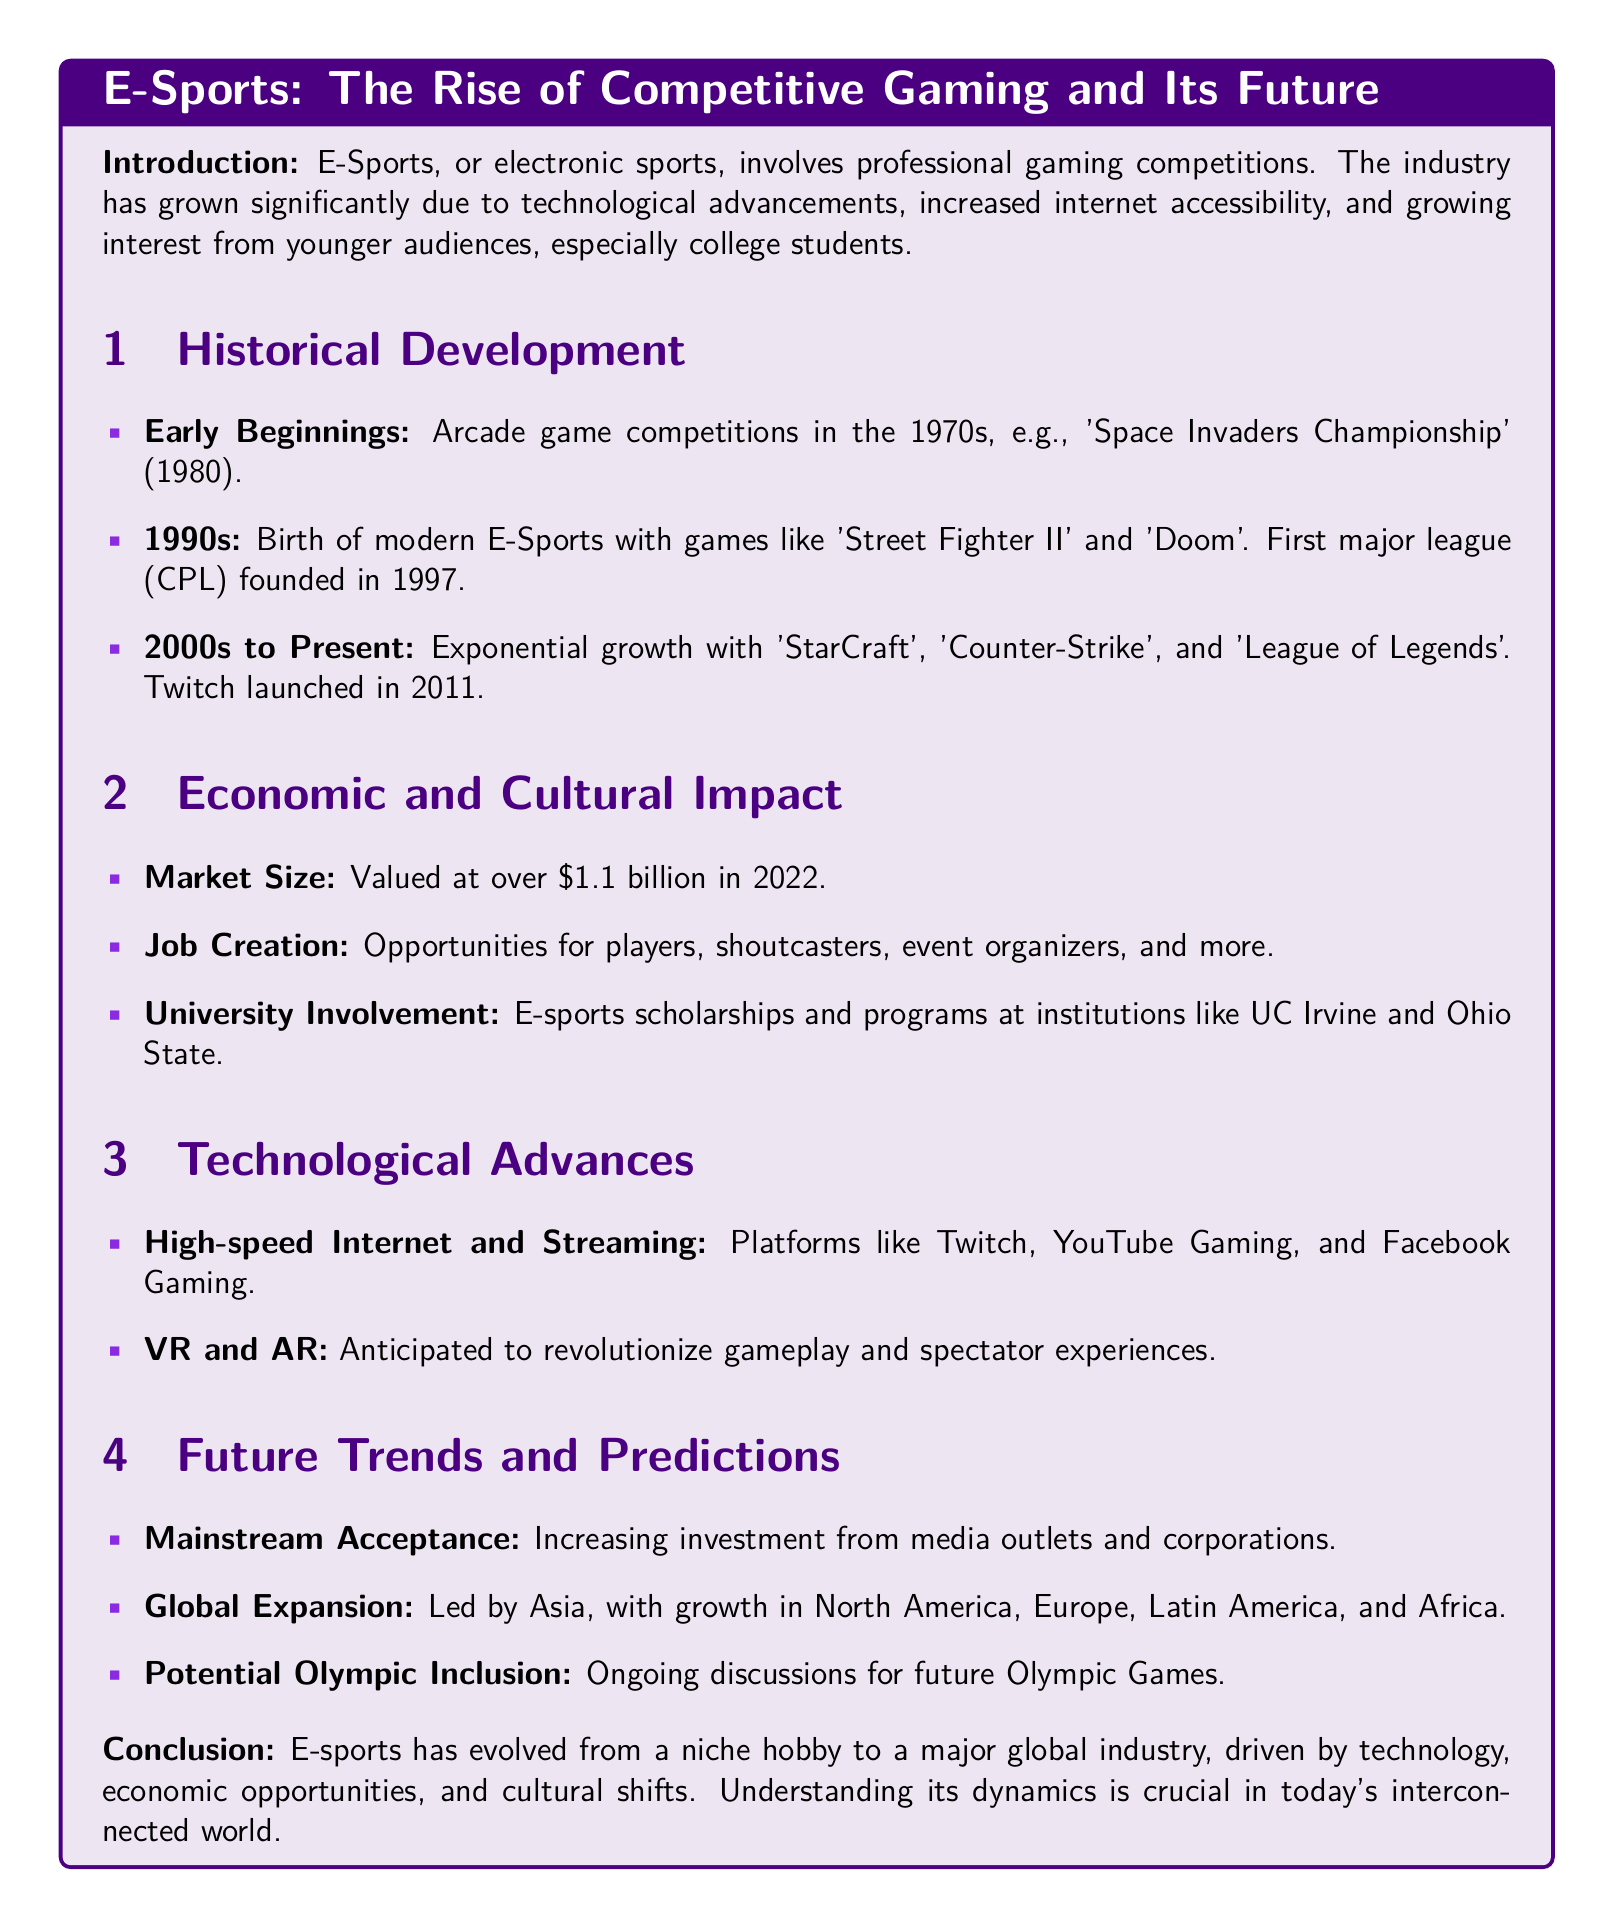What are E-Sports? E-Sports, or electronic sports, involves professional gaming competitions.
Answer: Professional gaming competitions When was the first major league founded? The first major league was founded in 1997, marking the birth of modern E-Sports.
Answer: 1997 What was the market size of E-Sports in 2022? The document states that the market was valued at over $1.1 billion in 2022.
Answer: Over $1.1 billion Which platforms have contributed to high-speed internet and streaming in E-Sports? The document mentions platforms like Twitch, YouTube Gaming, and Facebook Gaming.
Answer: Twitch, YouTube Gaming, Facebook Gaming What is the anticipated technological advance in E-Sports gameplay? The document indicates that VR and AR are anticipated to revolutionize gameplay and spectator experiences.
Answer: VR and AR How has university involvement influenced E-Sports? The involvement includes E-sports scholarships and programs at universities like UC Irvine and Ohio State.
Answer: Scholarships and programs What future trend is associated with Olympic discussions? The document mentions ongoing discussions about the potential inclusion of E-Sports in future Olympic Games.
Answer: Olympic inclusion Which region is leading global expansion in E-Sports? The document states that Asia is leading the global expansion in E-Sports.
Answer: Asia 